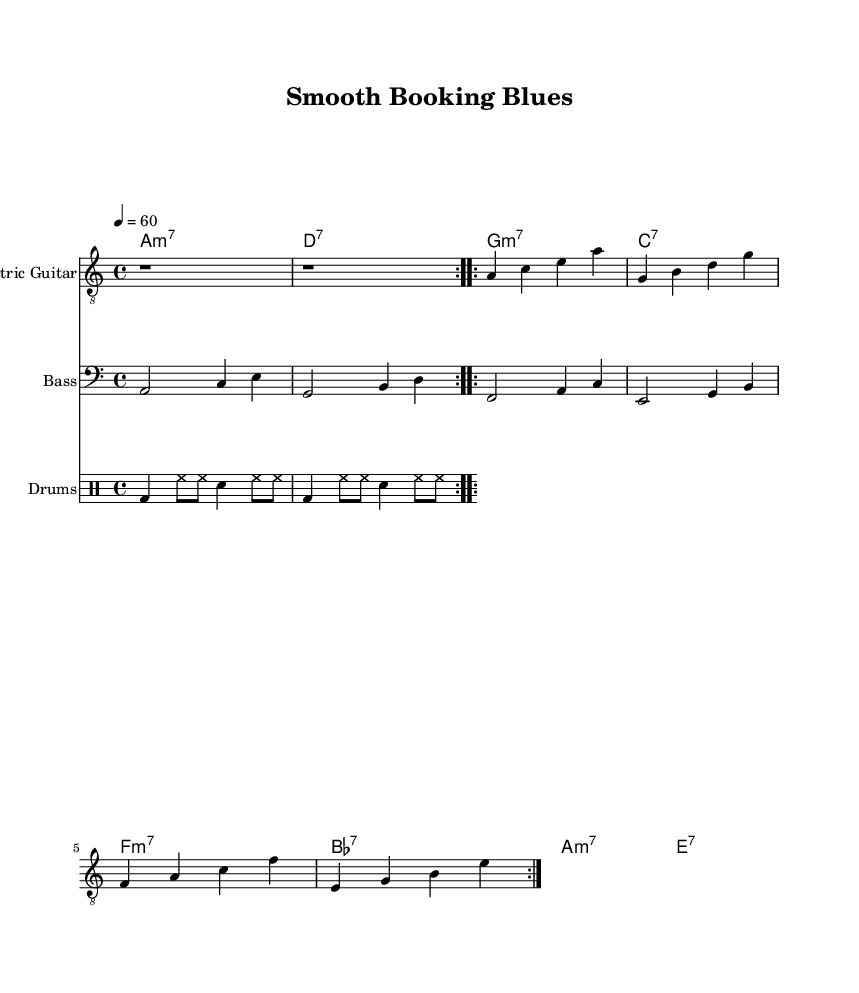What is the key signature of this music? The key signature is A minor, which has no sharps or flats. A minor is indicated by the absence of accidentals at the beginning of the staff.
Answer: A minor What is the time signature of this music? The time signature is 4/4, which allows four beats per measure and is indicated by the notation at the beginning of the piece. Each measure is organized into four quarter-note beats.
Answer: 4/4 What is the tempo marking of this piece? The tempo marking indicates a quarter note equals sixty beats per minute, which is a slow and relaxed pace suitable for winding down. This is shown in the tempo notation at the beginning of the score.
Answer: sixty How many times is the first section repeated? The first section of the electric guitar part is repeated two times, as indicated by the "volta" markings in the music. These markings guide performers to repeat the measures noted.
Answer: two What is the starting note of the electric guitar part? The electric guitar part begins with a rest, which is a pause in playing. This is specified at the start of the electric guitar measure.
Answer: rest What type of chords are used in the organ part? The organ part consists of seventh chords, which are indicated by the notation in the chord mode section. These chords typically add a dissonant and jazzy flavor that is characteristic of the electric blues genre.
Answer: seventh chords 